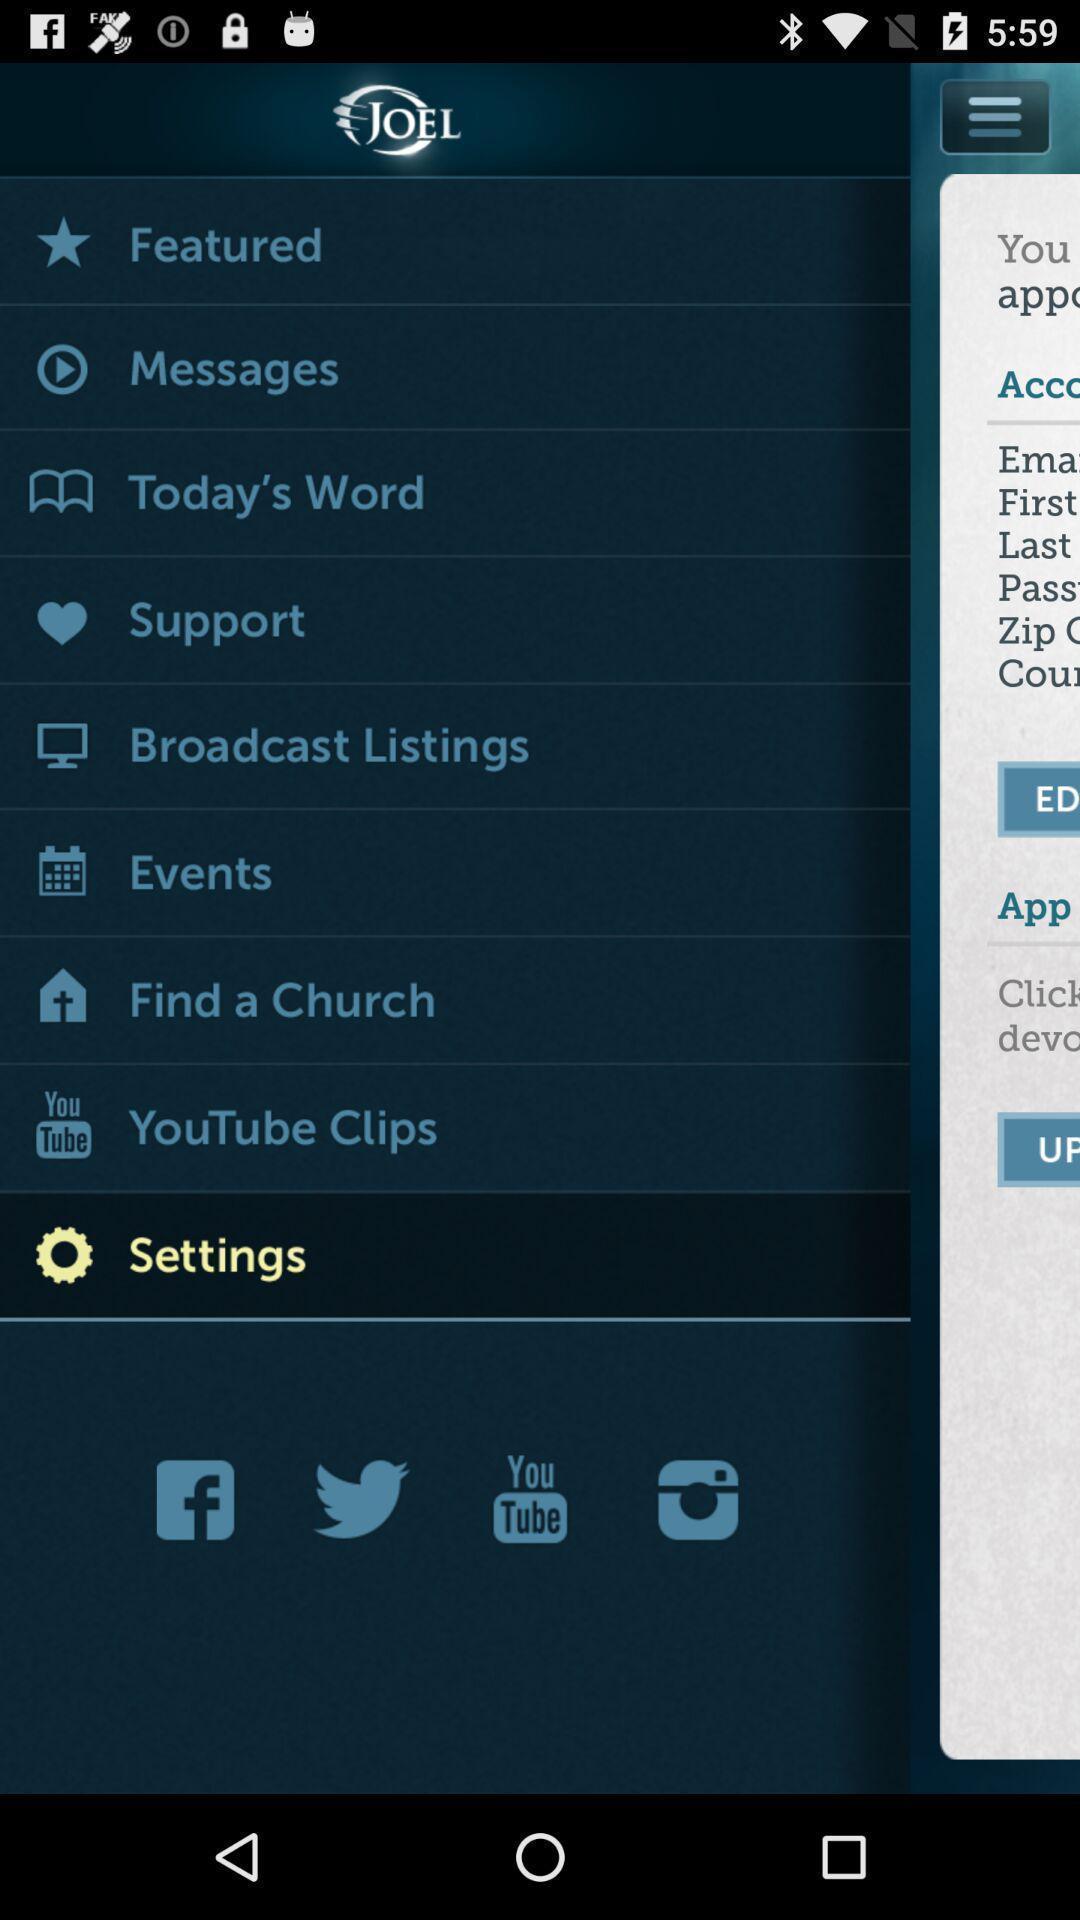Explain the elements present in this screenshot. Screen shows different options in a social app. 